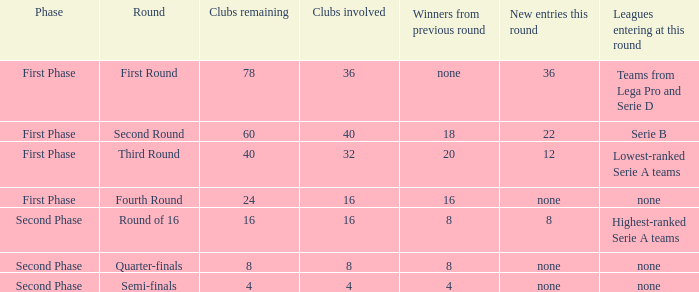The new entries this round was shown to be 12, in which phase would you find this? First Phase. 